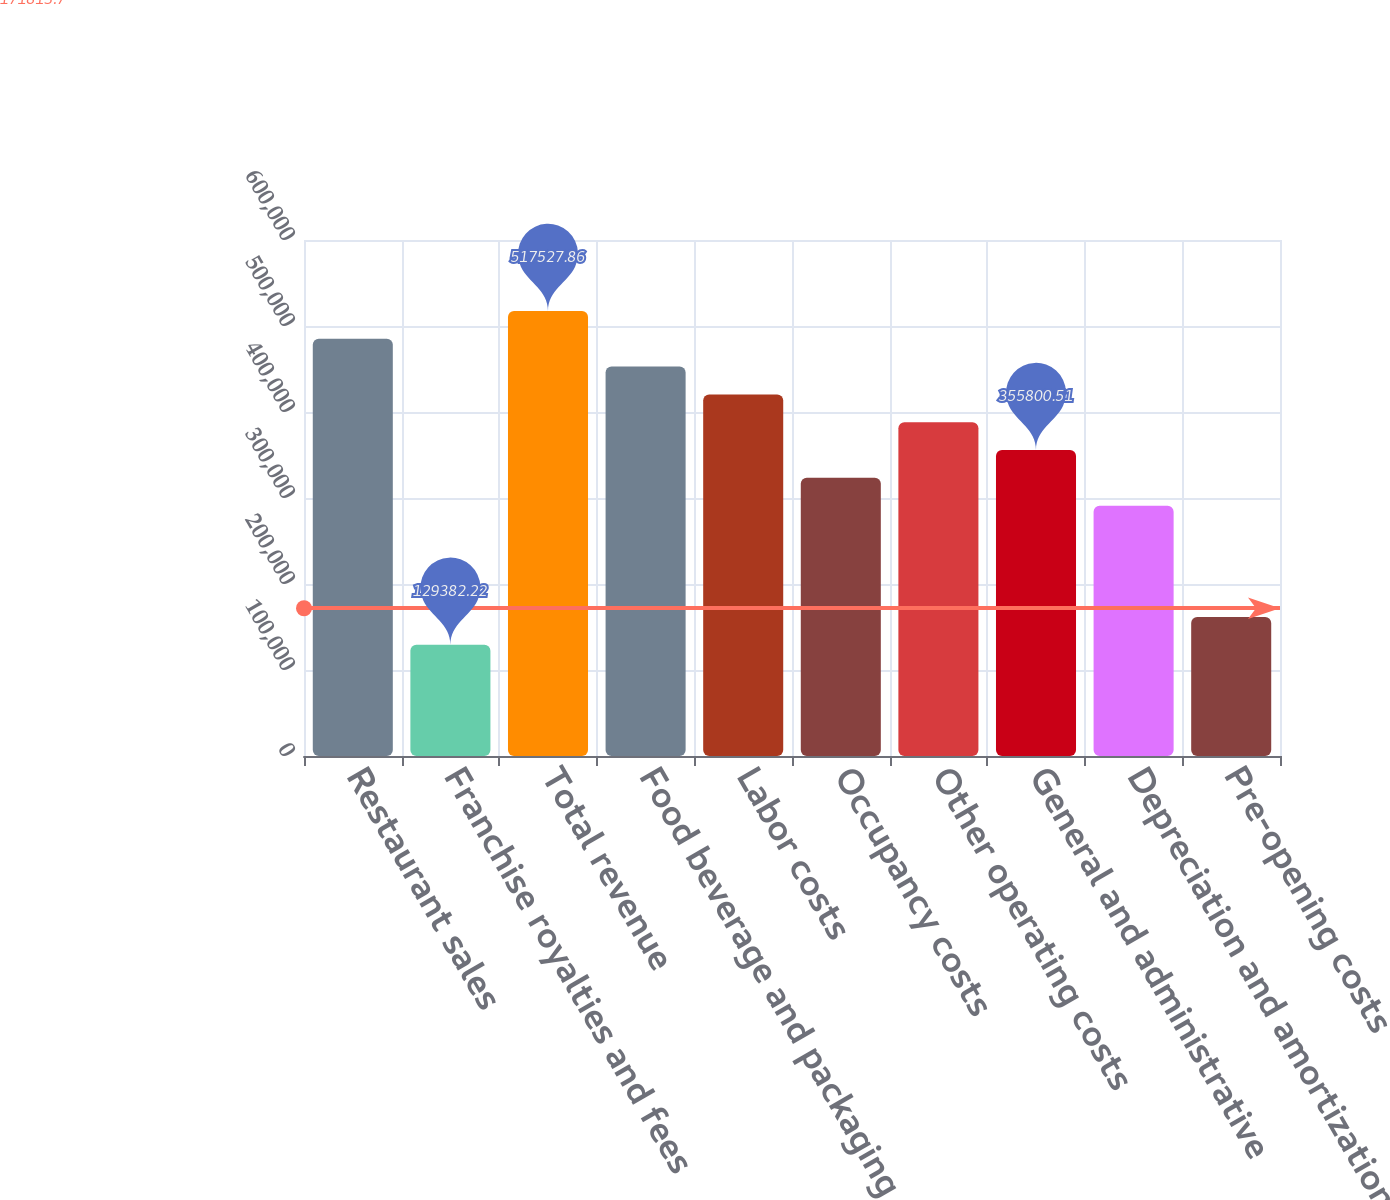Convert chart to OTSL. <chart><loc_0><loc_0><loc_500><loc_500><bar_chart><fcel>Restaurant sales<fcel>Franchise royalties and fees<fcel>Total revenue<fcel>Food beverage and packaging<fcel>Labor costs<fcel>Occupancy costs<fcel>Other operating costs<fcel>General and administrative<fcel>Depreciation and amortization<fcel>Pre-opening costs<nl><fcel>485182<fcel>129382<fcel>517528<fcel>452837<fcel>420491<fcel>323455<fcel>388146<fcel>355801<fcel>291110<fcel>161728<nl></chart> 